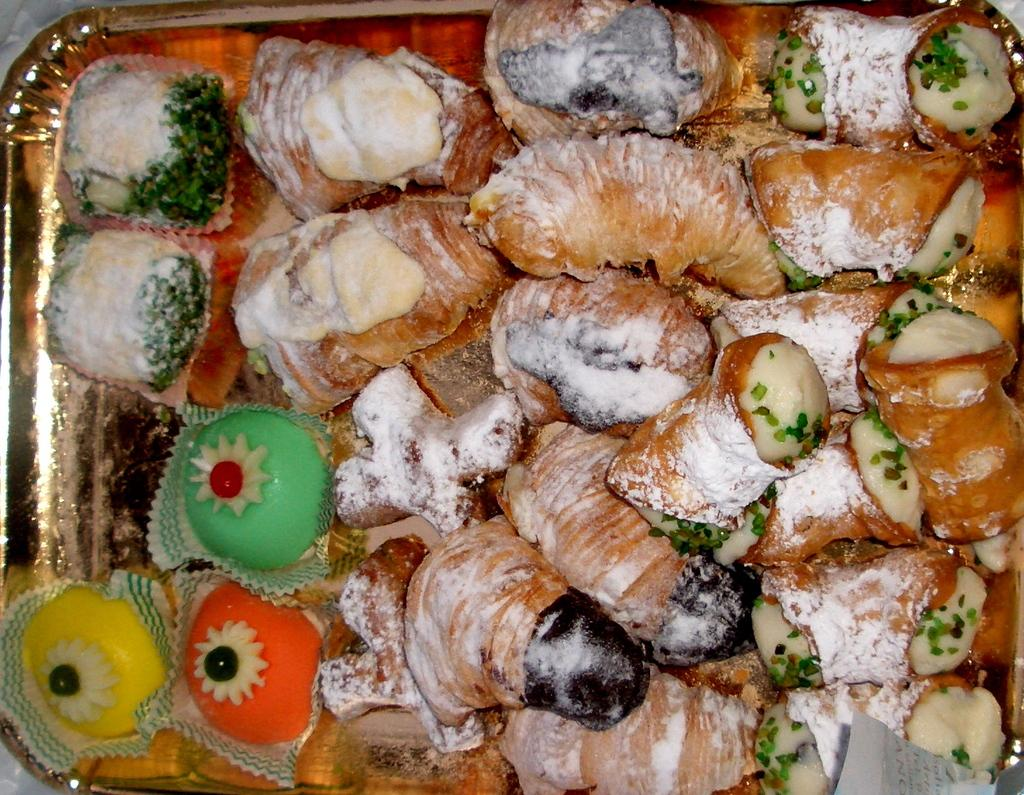What type of food items can be seen in the image? There are croissants and sweets in the image. Are there any other food items visible besides croissants and sweets? Yes, there are other food items in the image. How are the food items arranged in the image? The food items are placed on a tray. What is the color of the tray? The tray is gold in color. Can you see any pencils being used to draw on the croissants in the image? No, there are no pencils or any drawing activity visible on the croissants in the image. 